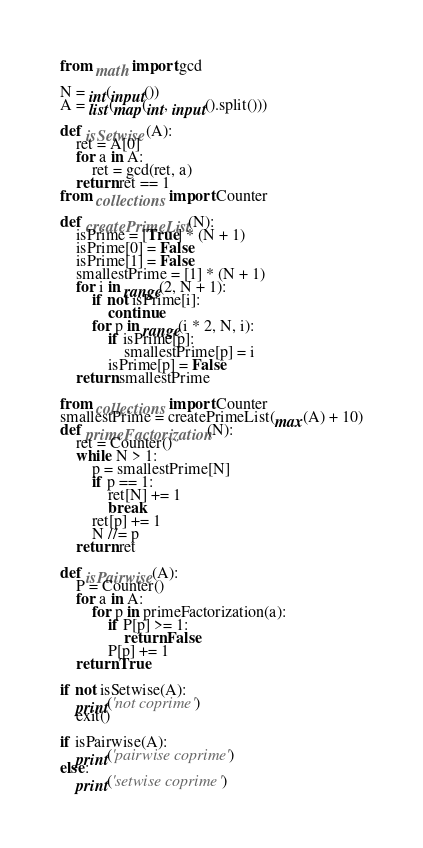<code> <loc_0><loc_0><loc_500><loc_500><_Python_>from math import gcd

N = int(input())
A = list(map(int, input().split()))

def isSetwise(A):
    ret = A[0]
    for a in A:
        ret = gcd(ret, a)
    return ret == 1
from collections import Counter

def createPrimeList(N):
    isPrime = [True] * (N + 1)
    isPrime[0] = False
    isPrime[1] = False
    smallestPrime = [1] * (N + 1)
    for i in range(2, N + 1):
        if not isPrime[i]:
            continue
        for p in range(i * 2, N, i):
            if isPrime[p]:
                smallestPrime[p] = i
            isPrime[p] = False
    return smallestPrime

from collections import Counter
smallestPrime = createPrimeList(max(A) + 10)
def primeFactorization(N):
    ret = Counter()
    while N > 1:
        p = smallestPrime[N]
        if p == 1:
            ret[N] += 1
            break
        ret[p] += 1
        N //= p
    return ret

def isPairwise(A):
    P = Counter()
    for a in A:
        for p in primeFactorization(a):
            if P[p] >= 1:
                return False
            P[p] += 1
    return True

if not isSetwise(A):
    print('not coprime')
    exit()

if isPairwise(A):
    print('pairwise coprime')
else:
    print('setwise coprime')
</code> 